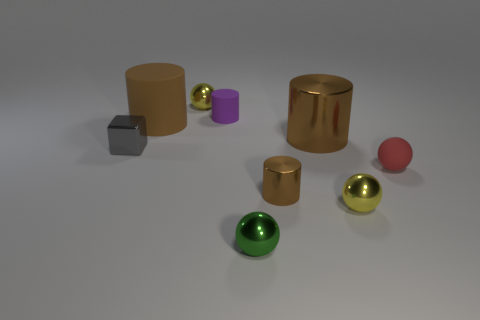How many big metal cylinders are behind the big matte thing?
Offer a terse response. 0. What is the color of the small cylinder that is made of the same material as the red thing?
Offer a very short reply. Purple. How many metal objects are either brown cylinders or small purple objects?
Provide a short and direct response. 2. Do the green ball and the tiny gray object have the same material?
Your answer should be very brief. Yes. There is a tiny rubber thing that is behind the metal block; what is its shape?
Provide a short and direct response. Cylinder. There is a yellow metal thing in front of the tiny red object; is there a tiny purple object that is in front of it?
Your response must be concise. No. Are there any green shiny objects of the same size as the brown matte thing?
Ensure brevity in your answer.  No. There is a sphere that is left of the green metallic object; does it have the same color as the small shiny block?
Your answer should be compact. No. The gray cube is what size?
Your answer should be compact. Small. What is the size of the yellow ball to the left of the tiny yellow metal object that is right of the small green metallic thing?
Keep it short and to the point. Small. 